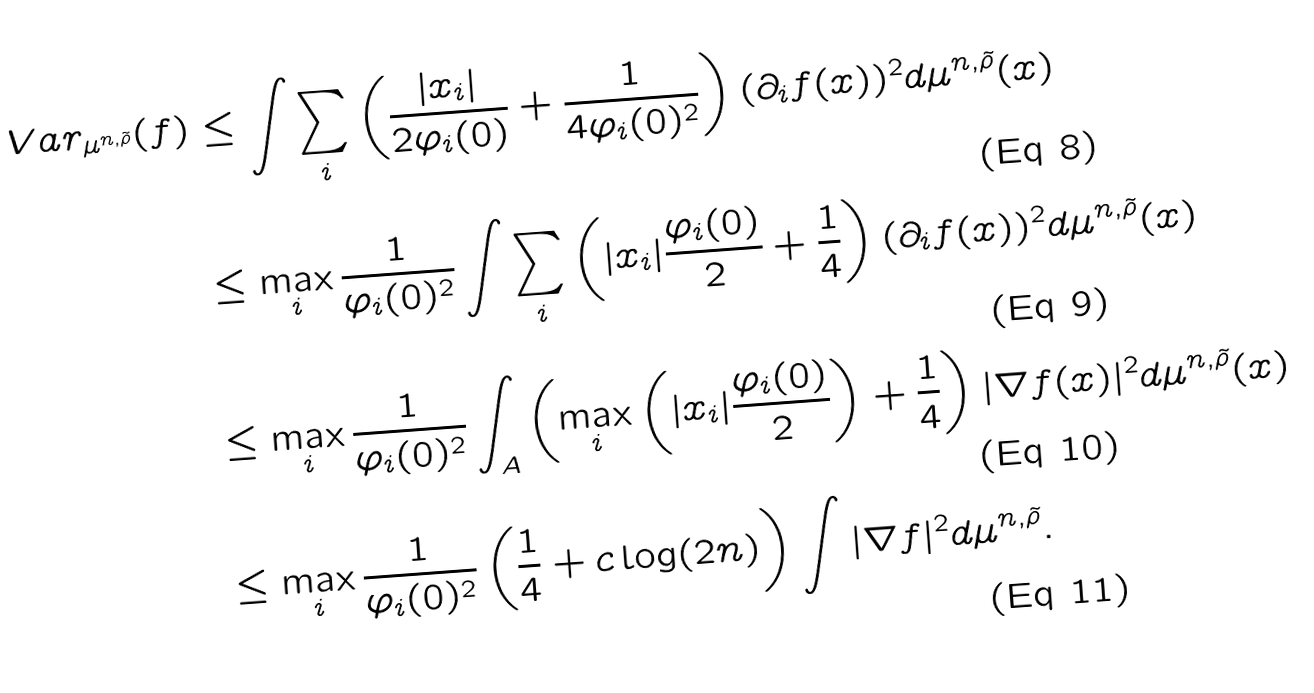Convert formula to latex. <formula><loc_0><loc_0><loc_500><loc_500>V a r _ { \mu ^ { n , \tilde { \rho } } } ( f ) & \leq \int \sum _ { i } \left ( \frac { | x _ { i } | } { 2 \varphi _ { i } ( 0 ) } + \frac { 1 } { 4 \varphi _ { i } ( 0 ) ^ { 2 } } \right ) ( \partial _ { i } f ( x ) ) ^ { 2 } d \mu ^ { n , \tilde { \rho } } ( x ) \\ & \leq \max _ { i } \frac { 1 } { \varphi _ { i } ( 0 ) ^ { 2 } } \int \sum _ { i } \left ( | x _ { i } | \frac { \varphi _ { i } ( 0 ) } { 2 } + \frac { 1 } { 4 } \right ) ( \partial _ { i } f ( x ) ) ^ { 2 } d \mu ^ { n , \tilde { \rho } } ( x ) \\ & \leq \max _ { i } \frac { 1 } { \varphi _ { i } ( 0 ) ^ { 2 } } \int _ { A } \left ( \max _ { i } \left ( | x _ { i } | \frac { \varphi _ { i } ( 0 ) } { 2 } \right ) + \frac { 1 } { 4 } \right ) | \nabla f ( x ) | ^ { 2 } d \mu ^ { n , \tilde { \rho } } ( x ) \\ & \leq \max _ { i } \frac { 1 } { \varphi _ { i } ( 0 ) ^ { 2 } } \left ( \frac { 1 } { 4 } + c \log ( 2 n ) \right ) \int | \nabla f | ^ { 2 } d \mu ^ { n , \tilde { \rho } } .</formula> 